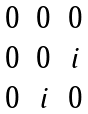Convert formula to latex. <formula><loc_0><loc_0><loc_500><loc_500>\begin{matrix} 0 & 0 & 0 \\ 0 & 0 & i \\ 0 & i & 0 \end{matrix}</formula> 